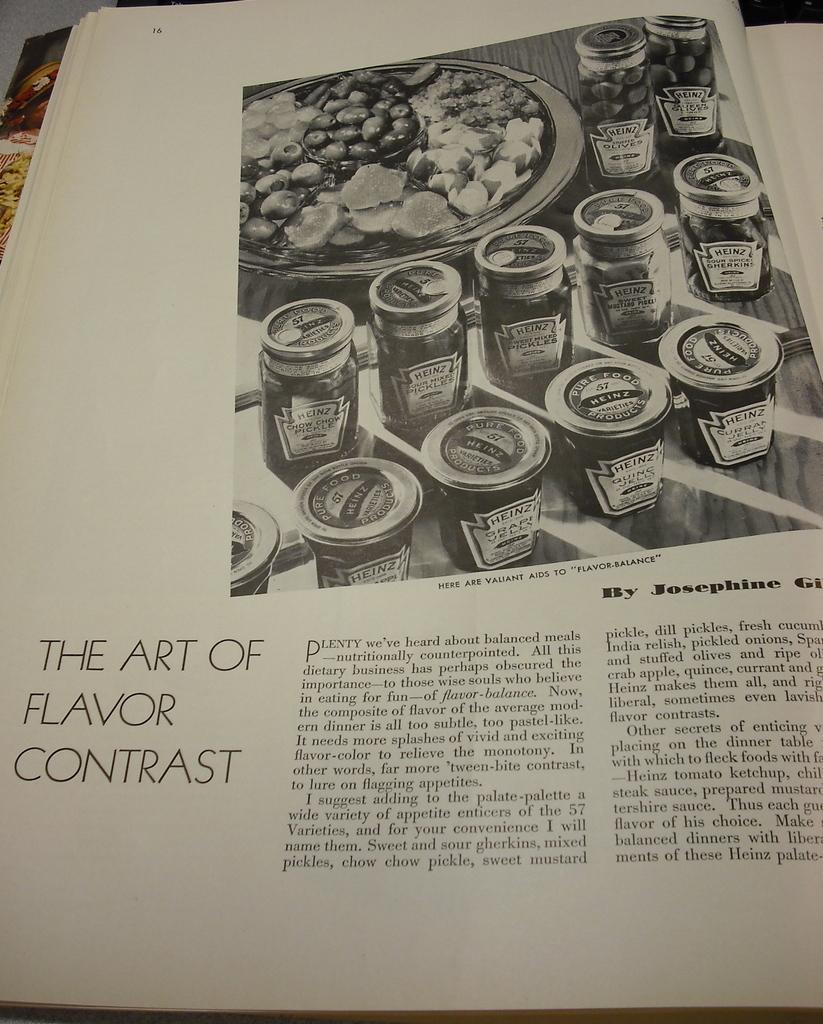What is the first name of the author of the article/?
Your answer should be compact. Josephine. 